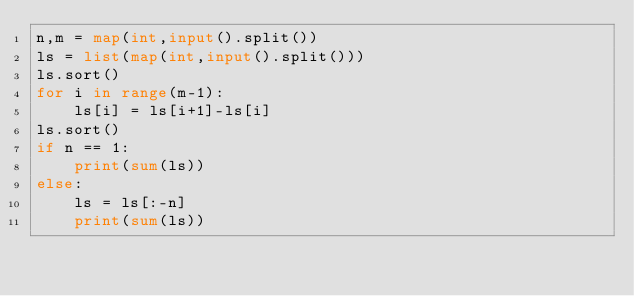<code> <loc_0><loc_0><loc_500><loc_500><_Python_>n,m = map(int,input().split())
ls = list(map(int,input().split()))
ls.sort()
for i in range(m-1):
    ls[i] = ls[i+1]-ls[i]
ls.sort()
if n == 1:
    print(sum(ls))
else:
    ls = ls[:-n]
    print(sum(ls))
</code> 